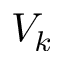Convert formula to latex. <formula><loc_0><loc_0><loc_500><loc_500>V _ { k }</formula> 